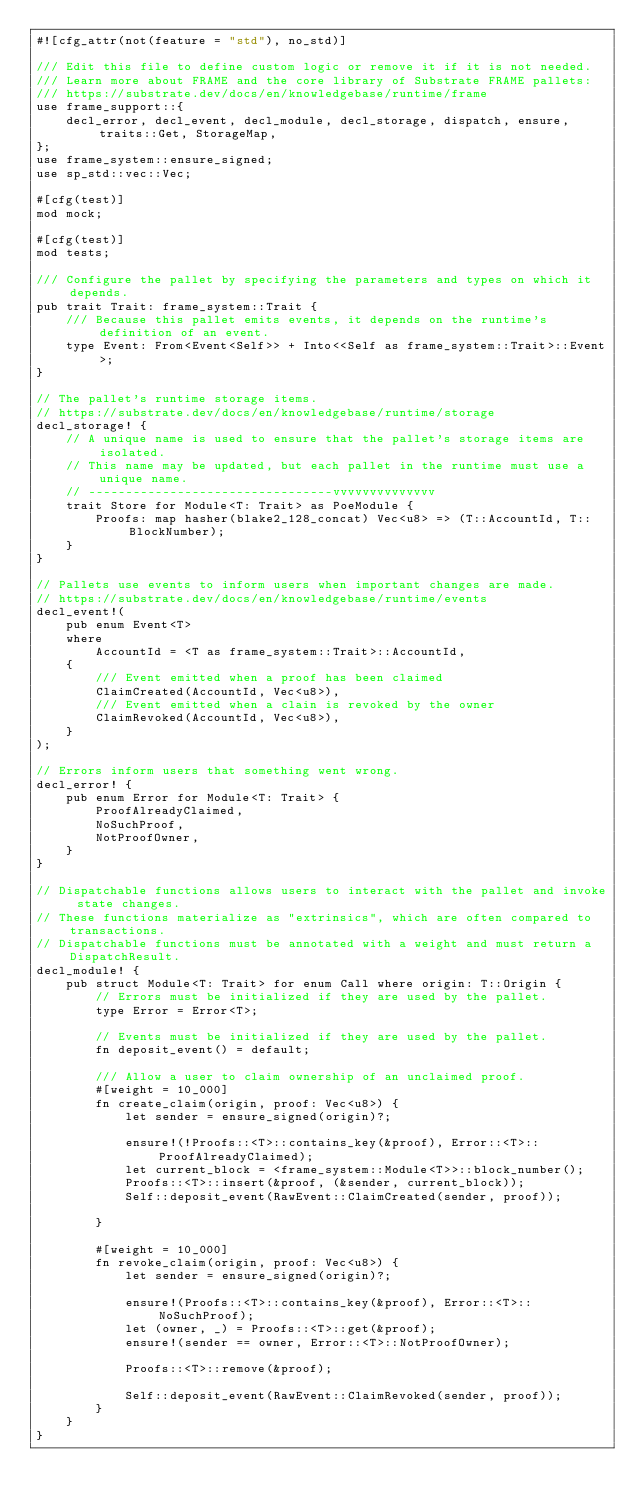Convert code to text. <code><loc_0><loc_0><loc_500><loc_500><_Rust_>#![cfg_attr(not(feature = "std"), no_std)]

/// Edit this file to define custom logic or remove it if it is not needed.
/// Learn more about FRAME and the core library of Substrate FRAME pallets:
/// https://substrate.dev/docs/en/knowledgebase/runtime/frame
use frame_support::{
    decl_error, decl_event, decl_module, decl_storage, dispatch, ensure, traits::Get, StorageMap,
};
use frame_system::ensure_signed;
use sp_std::vec::Vec;

#[cfg(test)]
mod mock;

#[cfg(test)]
mod tests;

/// Configure the pallet by specifying the parameters and types on which it depends.
pub trait Trait: frame_system::Trait {
    /// Because this pallet emits events, it depends on the runtime's definition of an event.
    type Event: From<Event<Self>> + Into<<Self as frame_system::Trait>::Event>;
}

// The pallet's runtime storage items.
// https://substrate.dev/docs/en/knowledgebase/runtime/storage
decl_storage! {
    // A unique name is used to ensure that the pallet's storage items are isolated.
    // This name may be updated, but each pallet in the runtime must use a unique name.
    // ---------------------------------vvvvvvvvvvvvvv
    trait Store for Module<T: Trait> as PoeModule {
        Proofs: map hasher(blake2_128_concat) Vec<u8> => (T::AccountId, T::BlockNumber);
    }
}

// Pallets use events to inform users when important changes are made.
// https://substrate.dev/docs/en/knowledgebase/runtime/events
decl_event!(
    pub enum Event<T>
    where
        AccountId = <T as frame_system::Trait>::AccountId,
    {
        /// Event emitted when a proof has been claimed
        ClaimCreated(AccountId, Vec<u8>),
        /// Event emitted when a clain is revoked by the owner
        ClaimRevoked(AccountId, Vec<u8>),
    }
);

// Errors inform users that something went wrong.
decl_error! {
    pub enum Error for Module<T: Trait> {
        ProofAlreadyClaimed,
        NoSuchProof,
        NotProofOwner,
    }
}

// Dispatchable functions allows users to interact with the pallet and invoke state changes.
// These functions materialize as "extrinsics", which are often compared to transactions.
// Dispatchable functions must be annotated with a weight and must return a DispatchResult.
decl_module! {
    pub struct Module<T: Trait> for enum Call where origin: T::Origin {
        // Errors must be initialized if they are used by the pallet.
        type Error = Error<T>;

        // Events must be initialized if they are used by the pallet.
        fn deposit_event() = default;

        /// Allow a user to claim ownership of an unclaimed proof.
        #[weight = 10_000]
        fn create_claim(origin, proof: Vec<u8>) {
            let sender = ensure_signed(origin)?;

            ensure!(!Proofs::<T>::contains_key(&proof), Error::<T>::ProofAlreadyClaimed);
            let current_block = <frame_system::Module<T>>::block_number();
            Proofs::<T>::insert(&proof, (&sender, current_block));
            Self::deposit_event(RawEvent::ClaimCreated(sender, proof));

        }

        #[weight = 10_000]
        fn revoke_claim(origin, proof: Vec<u8>) {
            let sender = ensure_signed(origin)?;

            ensure!(Proofs::<T>::contains_key(&proof), Error::<T>::NoSuchProof);
            let (owner, _) = Proofs::<T>::get(&proof);
            ensure!(sender == owner, Error::<T>::NotProofOwner);

            Proofs::<T>::remove(&proof);

            Self::deposit_event(RawEvent::ClaimRevoked(sender, proof));
        }
    }
}
</code> 